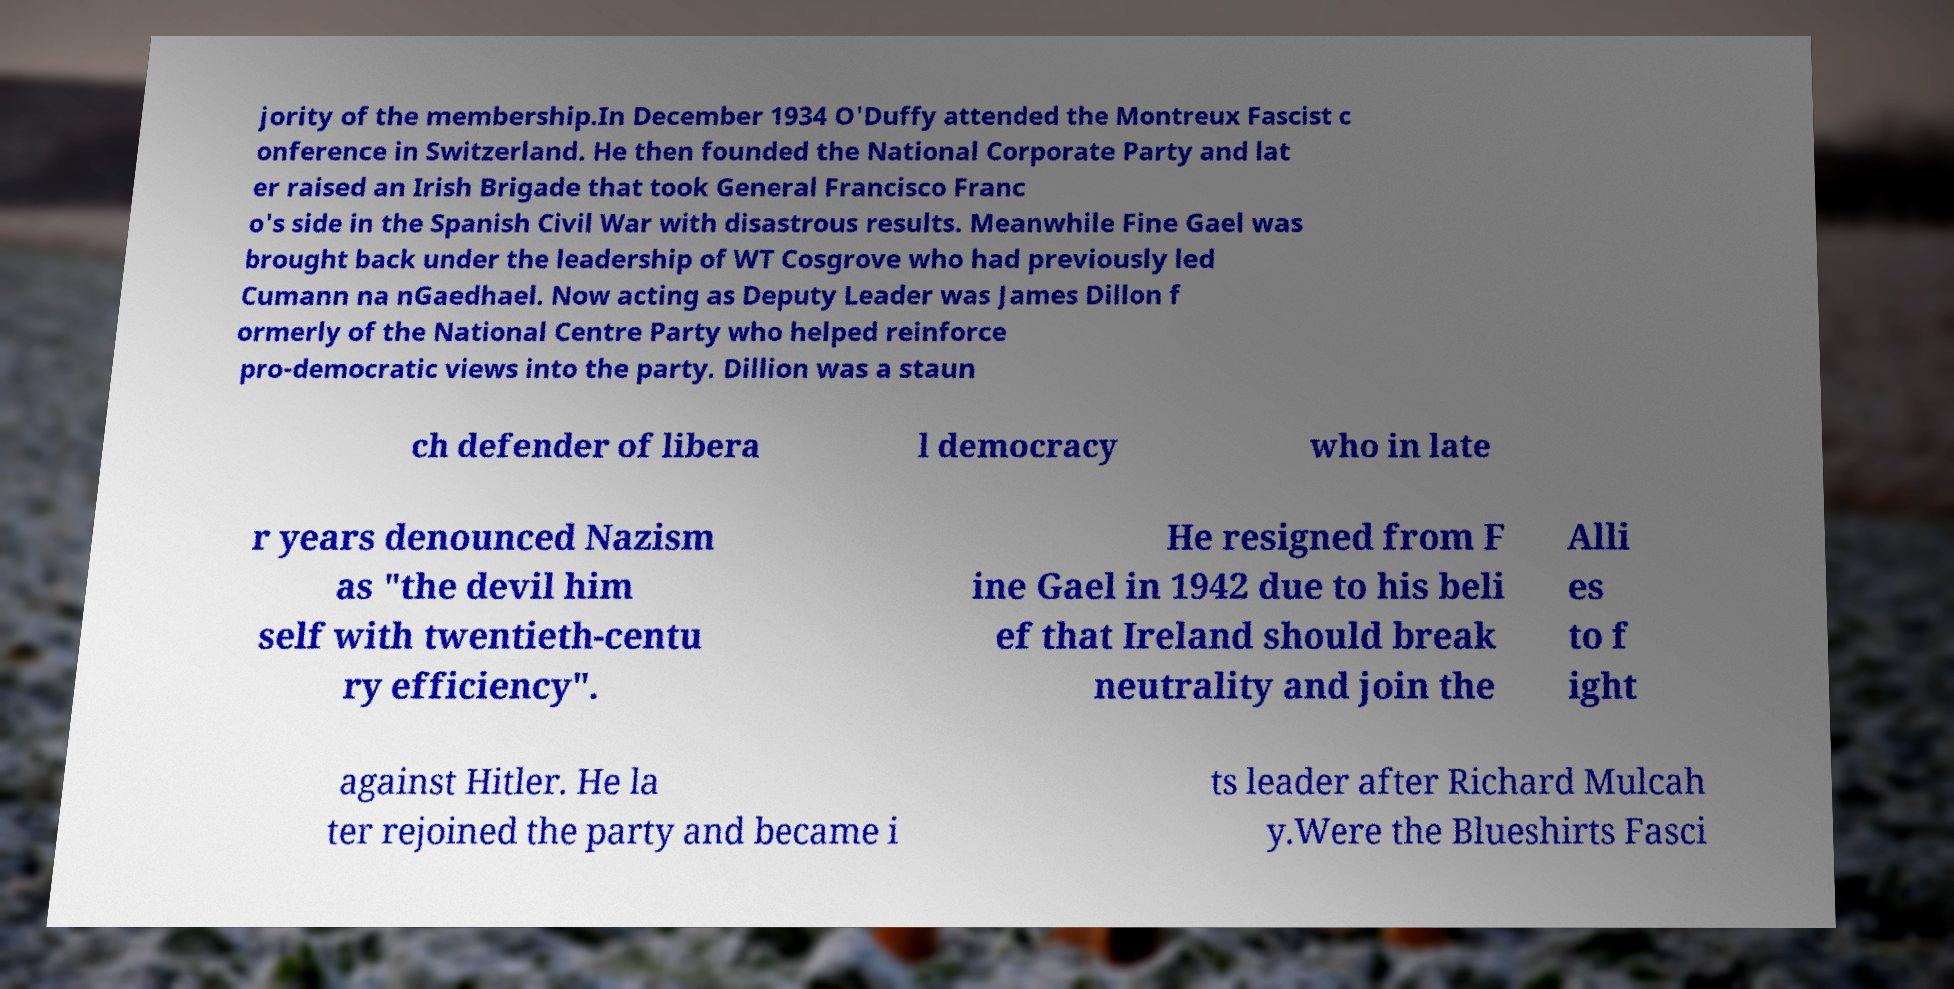Could you extract and type out the text from this image? jority of the membership.In December 1934 O'Duffy attended the Montreux Fascist c onference in Switzerland. He then founded the National Corporate Party and lat er raised an Irish Brigade that took General Francisco Franc o's side in the Spanish Civil War with disastrous results. Meanwhile Fine Gael was brought back under the leadership of WT Cosgrove who had previously led Cumann na nGaedhael. Now acting as Deputy Leader was James Dillon f ormerly of the National Centre Party who helped reinforce pro-democratic views into the party. Dillion was a staun ch defender of libera l democracy who in late r years denounced Nazism as "the devil him self with twentieth-centu ry efficiency". He resigned from F ine Gael in 1942 due to his beli ef that Ireland should break neutrality and join the Alli es to f ight against Hitler. He la ter rejoined the party and became i ts leader after Richard Mulcah y.Were the Blueshirts Fasci 